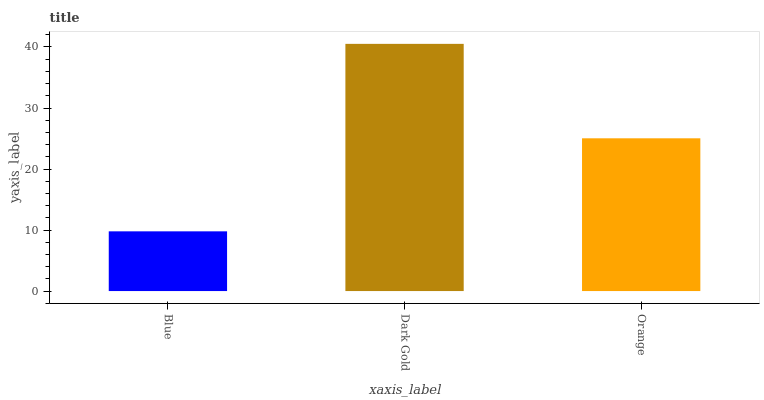Is Blue the minimum?
Answer yes or no. Yes. Is Dark Gold the maximum?
Answer yes or no. Yes. Is Orange the minimum?
Answer yes or no. No. Is Orange the maximum?
Answer yes or no. No. Is Dark Gold greater than Orange?
Answer yes or no. Yes. Is Orange less than Dark Gold?
Answer yes or no. Yes. Is Orange greater than Dark Gold?
Answer yes or no. No. Is Dark Gold less than Orange?
Answer yes or no. No. Is Orange the high median?
Answer yes or no. Yes. Is Orange the low median?
Answer yes or no. Yes. Is Blue the high median?
Answer yes or no. No. Is Dark Gold the low median?
Answer yes or no. No. 